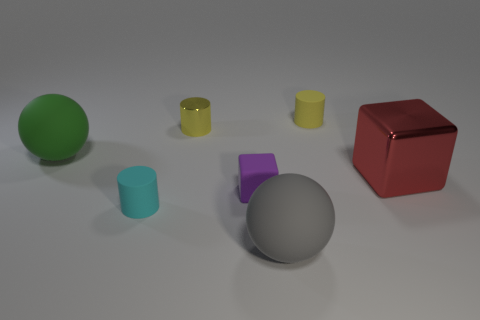There is another thing that is the same color as the tiny metal object; what is it made of?
Make the answer very short. Rubber. Are there fewer tiny things than small cyan rubber cylinders?
Offer a terse response. No. There is a cylinder that is in front of the big red cube; is its color the same as the large cube?
Offer a very short reply. No. There is a block that is the same material as the small cyan thing; what is its color?
Offer a very short reply. Purple. Is the size of the gray sphere the same as the purple matte cube?
Ensure brevity in your answer.  No. What material is the purple block?
Ensure brevity in your answer.  Rubber. What material is the block that is the same size as the cyan rubber thing?
Your answer should be compact. Rubber. Are there any gray matte spheres of the same size as the yellow shiny cylinder?
Make the answer very short. No. Is the number of large red cubes in front of the big red object the same as the number of large gray rubber objects behind the yellow metal cylinder?
Your response must be concise. Yes. Is the number of large green balls greater than the number of large yellow balls?
Provide a succinct answer. Yes. 